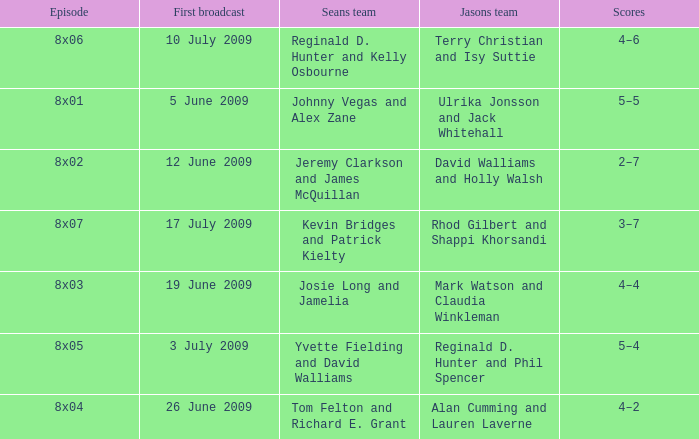Could you parse the entire table as a dict? {'header': ['Episode', 'First broadcast', 'Seans team', 'Jasons team', 'Scores'], 'rows': [['8x06', '10 July 2009', 'Reginald D. Hunter and Kelly Osbourne', 'Terry Christian and Isy Suttie', '4–6'], ['8x01', '5 June 2009', 'Johnny Vegas and Alex Zane', 'Ulrika Jonsson and Jack Whitehall', '5–5'], ['8x02', '12 June 2009', 'Jeremy Clarkson and James McQuillan', 'David Walliams and Holly Walsh', '2–7'], ['8x07', '17 July 2009', 'Kevin Bridges and Patrick Kielty', 'Rhod Gilbert and Shappi Khorsandi', '3–7'], ['8x03', '19 June 2009', 'Josie Long and Jamelia', 'Mark Watson and Claudia Winkleman', '4–4'], ['8x05', '3 July 2009', 'Yvette Fielding and David Walliams', 'Reginald D. Hunter and Phil Spencer', '5–4'], ['8x04', '26 June 2009', 'Tom Felton and Richard E. Grant', 'Alan Cumming and Lauren Laverne', '4–2']]} Who was on Jason's team in the episode where Sean's team was Reginald D. Hunter and Kelly Osbourne? Terry Christian and Isy Suttie. 